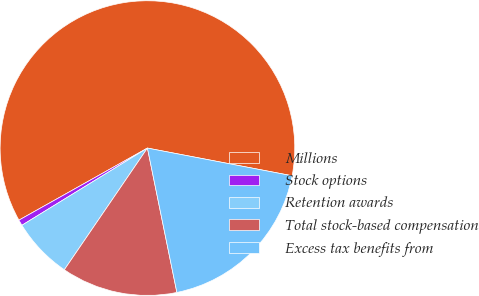Convert chart. <chart><loc_0><loc_0><loc_500><loc_500><pie_chart><fcel>Millions<fcel>Stock options<fcel>Retention awards<fcel>Total stock-based compensation<fcel>Excess tax benefits from<nl><fcel>61.15%<fcel>0.64%<fcel>6.69%<fcel>12.74%<fcel>18.79%<nl></chart> 